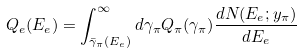<formula> <loc_0><loc_0><loc_500><loc_500>Q _ { e } ( E _ { e } ) = \int ^ { \infty } _ { \bar { \gamma } _ { \pi } ( E _ { e } ) } d \gamma _ { \pi } Q _ { \pi } ( \gamma _ { \pi } ) \frac { d N ( E _ { e } ; y _ { \pi } ) } { d E _ { e } }</formula> 